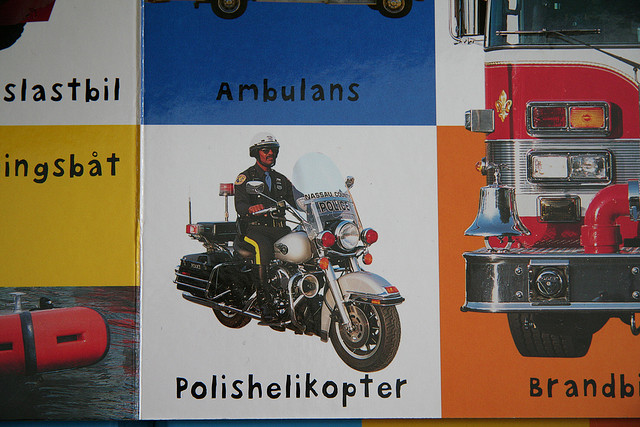Identify and read out the text in this image. Ambulans slastbil ingsbat Nasseas POLICE Polishelikopter Brandb 